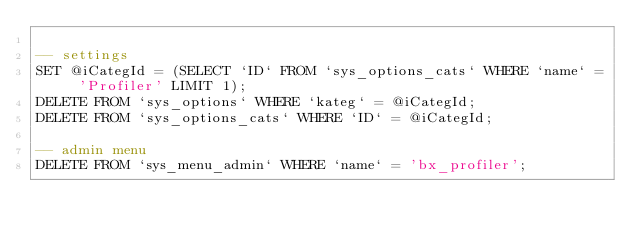<code> <loc_0><loc_0><loc_500><loc_500><_SQL_>
-- settings
SET @iCategId = (SELECT `ID` FROM `sys_options_cats` WHERE `name` = 'Profiler' LIMIT 1);
DELETE FROM `sys_options` WHERE `kateg` = @iCategId;
DELETE FROM `sys_options_cats` WHERE `ID` = @iCategId;

-- admin menu
DELETE FROM `sys_menu_admin` WHERE `name` = 'bx_profiler';
</code> 